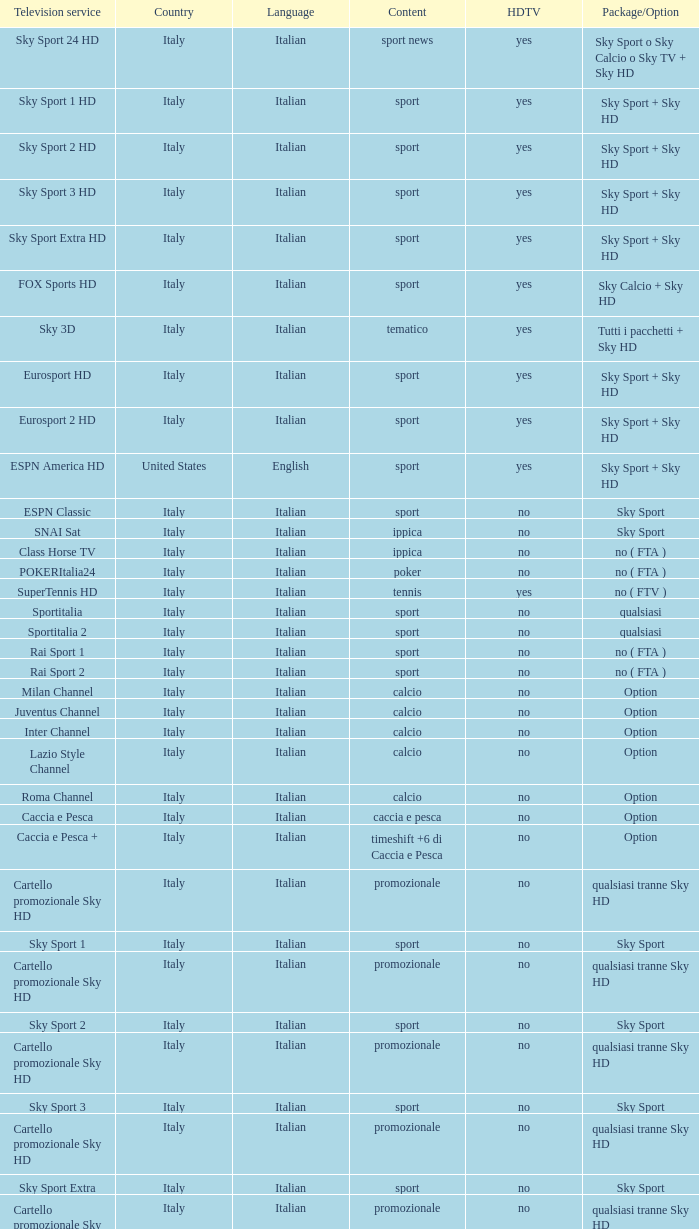What does the television service entail when the content is calcio and the package/option is option? Milan Channel, Juventus Channel, Inter Channel, Lazio Style Channel, Roma Channel. I'm looking to parse the entire table for insights. Could you assist me with that? {'header': ['Television service', 'Country', 'Language', 'Content', 'HDTV', 'Package/Option'], 'rows': [['Sky Sport 24 HD', 'Italy', 'Italian', 'sport news', 'yes', 'Sky Sport o Sky Calcio o Sky TV + Sky HD'], ['Sky Sport 1 HD', 'Italy', 'Italian', 'sport', 'yes', 'Sky Sport + Sky HD'], ['Sky Sport 2 HD', 'Italy', 'Italian', 'sport', 'yes', 'Sky Sport + Sky HD'], ['Sky Sport 3 HD', 'Italy', 'Italian', 'sport', 'yes', 'Sky Sport + Sky HD'], ['Sky Sport Extra HD', 'Italy', 'Italian', 'sport', 'yes', 'Sky Sport + Sky HD'], ['FOX Sports HD', 'Italy', 'Italian', 'sport', 'yes', 'Sky Calcio + Sky HD'], ['Sky 3D', 'Italy', 'Italian', 'tematico', 'yes', 'Tutti i pacchetti + Sky HD'], ['Eurosport HD', 'Italy', 'Italian', 'sport', 'yes', 'Sky Sport + Sky HD'], ['Eurosport 2 HD', 'Italy', 'Italian', 'sport', 'yes', 'Sky Sport + Sky HD'], ['ESPN America HD', 'United States', 'English', 'sport', 'yes', 'Sky Sport + Sky HD'], ['ESPN Classic', 'Italy', 'Italian', 'sport', 'no', 'Sky Sport'], ['SNAI Sat', 'Italy', 'Italian', 'ippica', 'no', 'Sky Sport'], ['Class Horse TV', 'Italy', 'Italian', 'ippica', 'no', 'no ( FTA )'], ['POKERItalia24', 'Italy', 'Italian', 'poker', 'no', 'no ( FTA )'], ['SuperTennis HD', 'Italy', 'Italian', 'tennis', 'yes', 'no ( FTV )'], ['Sportitalia', 'Italy', 'Italian', 'sport', 'no', 'qualsiasi'], ['Sportitalia 2', 'Italy', 'Italian', 'sport', 'no', 'qualsiasi'], ['Rai Sport 1', 'Italy', 'Italian', 'sport', 'no', 'no ( FTA )'], ['Rai Sport 2', 'Italy', 'Italian', 'sport', 'no', 'no ( FTA )'], ['Milan Channel', 'Italy', 'Italian', 'calcio', 'no', 'Option'], ['Juventus Channel', 'Italy', 'Italian', 'calcio', 'no', 'Option'], ['Inter Channel', 'Italy', 'Italian', 'calcio', 'no', 'Option'], ['Lazio Style Channel', 'Italy', 'Italian', 'calcio', 'no', 'Option'], ['Roma Channel', 'Italy', 'Italian', 'calcio', 'no', 'Option'], ['Caccia e Pesca', 'Italy', 'Italian', 'caccia e pesca', 'no', 'Option'], ['Caccia e Pesca +', 'Italy', 'Italian', 'timeshift +6 di Caccia e Pesca', 'no', 'Option'], ['Cartello promozionale Sky HD', 'Italy', 'Italian', 'promozionale', 'no', 'qualsiasi tranne Sky HD'], ['Sky Sport 1', 'Italy', 'Italian', 'sport', 'no', 'Sky Sport'], ['Cartello promozionale Sky HD', 'Italy', 'Italian', 'promozionale', 'no', 'qualsiasi tranne Sky HD'], ['Sky Sport 2', 'Italy', 'Italian', 'sport', 'no', 'Sky Sport'], ['Cartello promozionale Sky HD', 'Italy', 'Italian', 'promozionale', 'no', 'qualsiasi tranne Sky HD'], ['Sky Sport 3', 'Italy', 'Italian', 'sport', 'no', 'Sky Sport'], ['Cartello promozionale Sky HD', 'Italy', 'Italian', 'promozionale', 'no', 'qualsiasi tranne Sky HD'], ['Sky Sport Extra', 'Italy', 'Italian', 'sport', 'no', 'Sky Sport'], ['Cartello promozionale Sky HD', 'Italy', 'Italian', 'promozionale', 'no', 'qualsiasi tranne Sky HD'], ['Sky Supercalcio', 'Italy', 'Italian', 'calcio', 'no', 'Sky Calcio'], ['Cartello promozionale Sky HD', 'Italy', 'Italian', 'promozionale', 'no', 'qualsiasi tranne Sky HD'], ['Eurosport', 'Italy', 'Italian', 'sport', 'no', 'Sky Sport'], ['Eurosport 2', 'Italy', 'Italian', 'sport', 'no', 'Sky Sport'], ['ESPN America', 'Italy', 'Italian', 'sport', 'no', 'Sky Sport']]} 